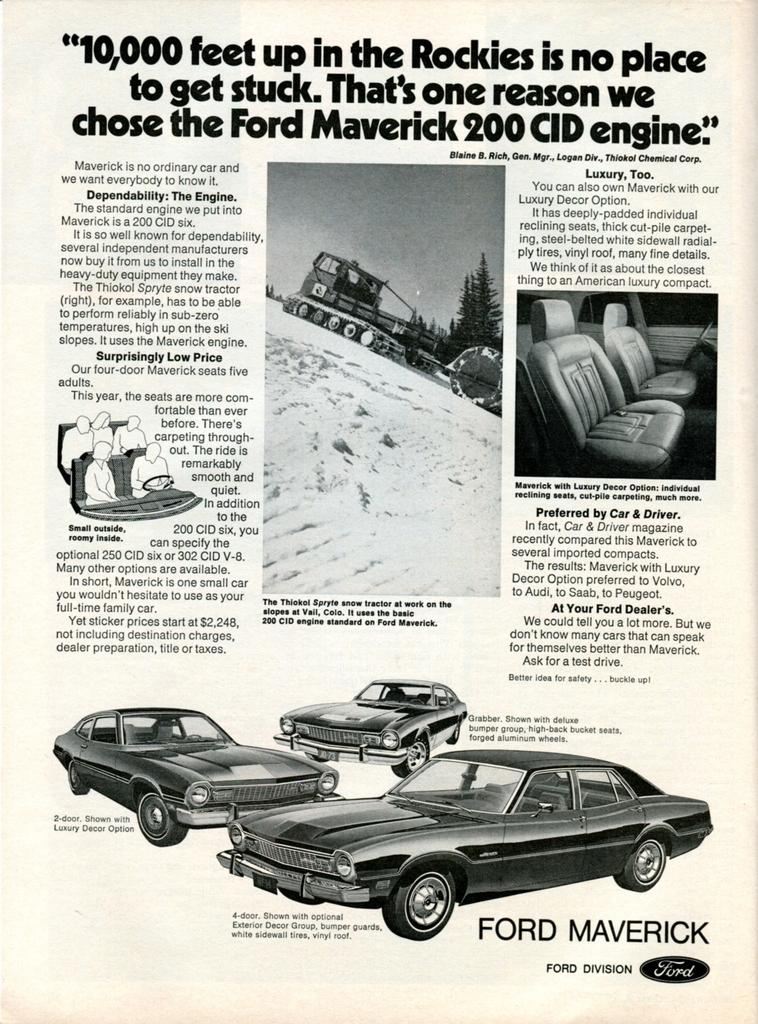What type of vehicles are depicted in the black and white pictures in the image? There are black and white pictures of cars in the image. What can be seen in the image besides the pictures of cars? There are seats visible in the image. What is the setting of the vehicle in the image? The vehicle is on the snow in the image. What brand or company might be associated with the image? There is a logo in the image, which could be associated with a brand or company. What additional information is provided in the image? There is some text in the image. What type of seed is being planted in the mine in the image? There is no seed or mine present in the image; it features black and white pictures of cars, seats, a vehicle on the snow, a logo, and some text. 